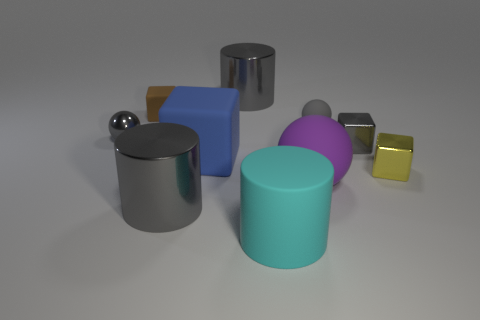Subtract all metal cylinders. How many cylinders are left? 1 Subtract all brown cylinders. How many gray spheres are left? 2 Subtract all blocks. How many objects are left? 6 Subtract all gray cylinders. How many cylinders are left? 1 Subtract 1 cylinders. How many cylinders are left? 2 Subtract all large purple rubber objects. Subtract all rubber things. How many objects are left? 4 Add 8 brown objects. How many brown objects are left? 9 Add 2 gray cylinders. How many gray cylinders exist? 4 Subtract 1 purple balls. How many objects are left? 9 Subtract all red blocks. Subtract all blue spheres. How many blocks are left? 4 